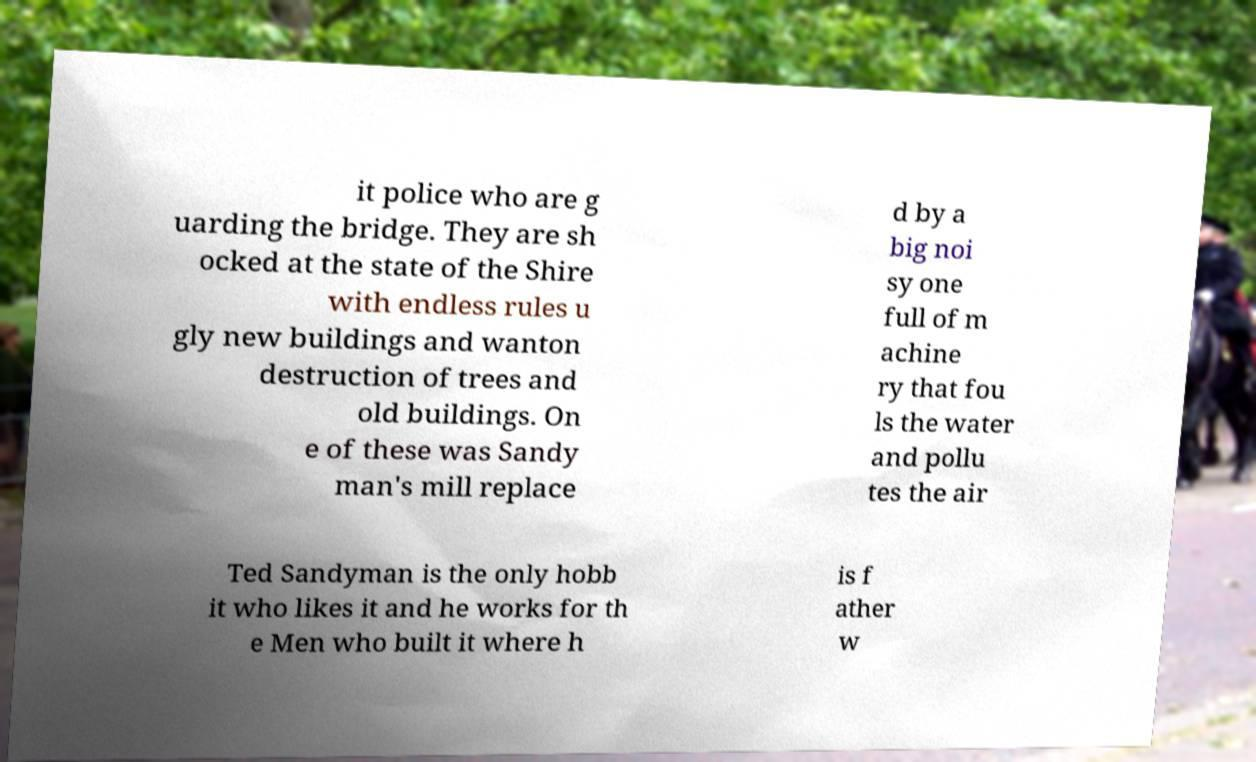Could you extract and type out the text from this image? it police who are g uarding the bridge. They are sh ocked at the state of the Shire with endless rules u gly new buildings and wanton destruction of trees and old buildings. On e of these was Sandy man's mill replace d by a big noi sy one full of m achine ry that fou ls the water and pollu tes the air Ted Sandyman is the only hobb it who likes it and he works for th e Men who built it where h is f ather w 